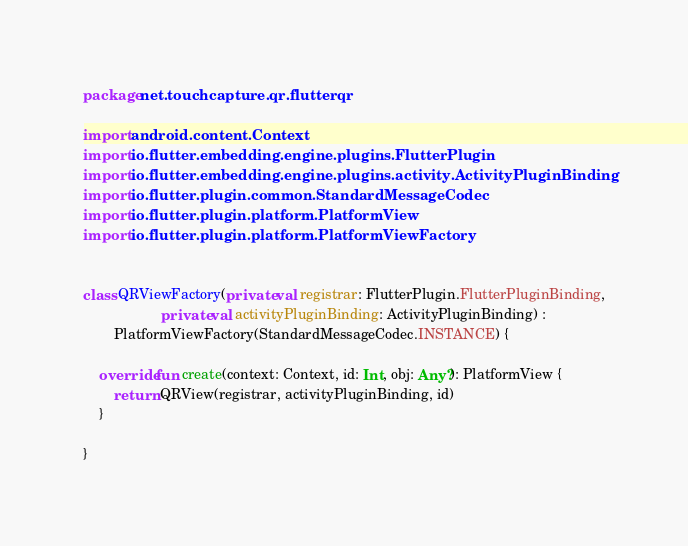Convert code to text. <code><loc_0><loc_0><loc_500><loc_500><_Kotlin_>package net.touchcapture.qr.flutterqr

import android.content.Context
import io.flutter.embedding.engine.plugins.FlutterPlugin
import io.flutter.embedding.engine.plugins.activity.ActivityPluginBinding
import io.flutter.plugin.common.StandardMessageCodec
import io.flutter.plugin.platform.PlatformView
import io.flutter.plugin.platform.PlatformViewFactory


class QRViewFactory(private val registrar: FlutterPlugin.FlutterPluginBinding,
                    private val activityPluginBinding: ActivityPluginBinding) :
        PlatformViewFactory(StandardMessageCodec.INSTANCE) {

    override fun create(context: Context, id: Int, obj: Any?): PlatformView {
        return QRView(registrar, activityPluginBinding, id)
    }

}</code> 